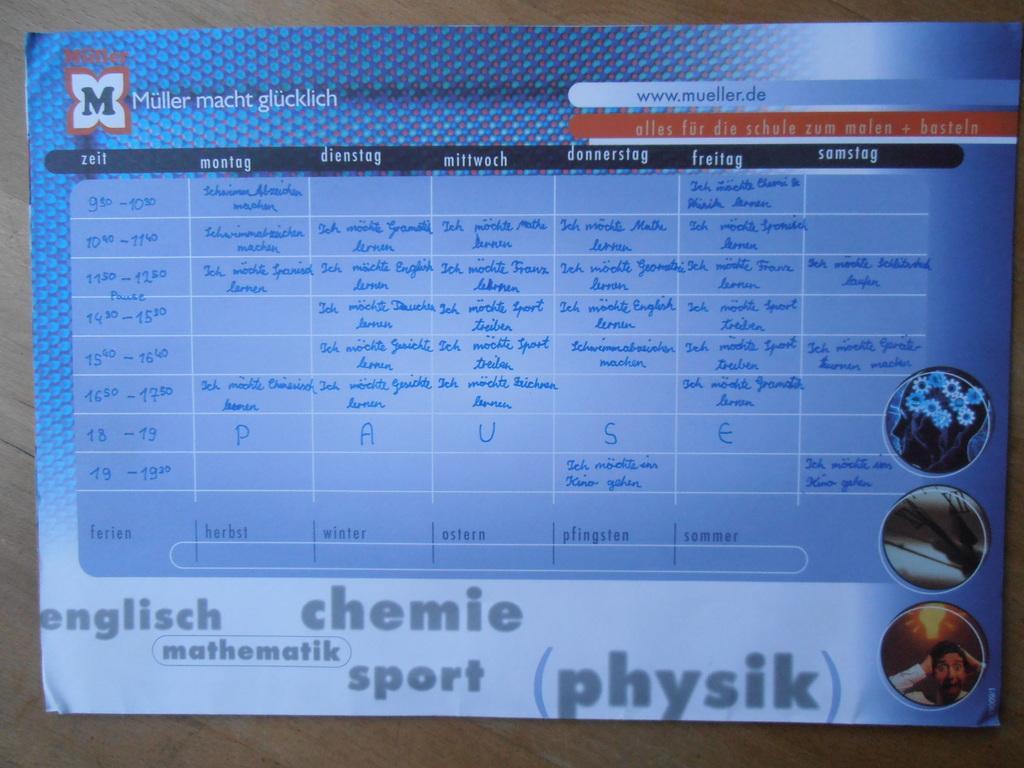In one or two sentences, can you explain what this image depicts? In this image there is a poster with pictures and some text on it is attached to the wall. 